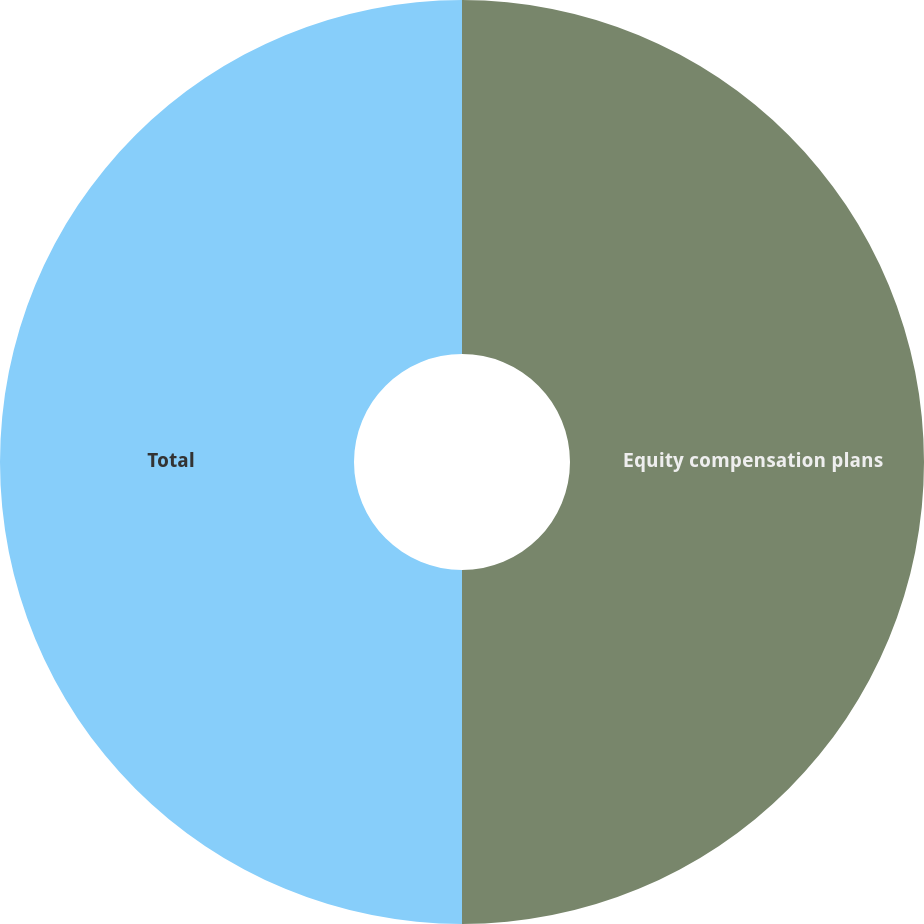Convert chart. <chart><loc_0><loc_0><loc_500><loc_500><pie_chart><fcel>Equity compensation plans<fcel>Total<nl><fcel>50.0%<fcel>50.0%<nl></chart> 